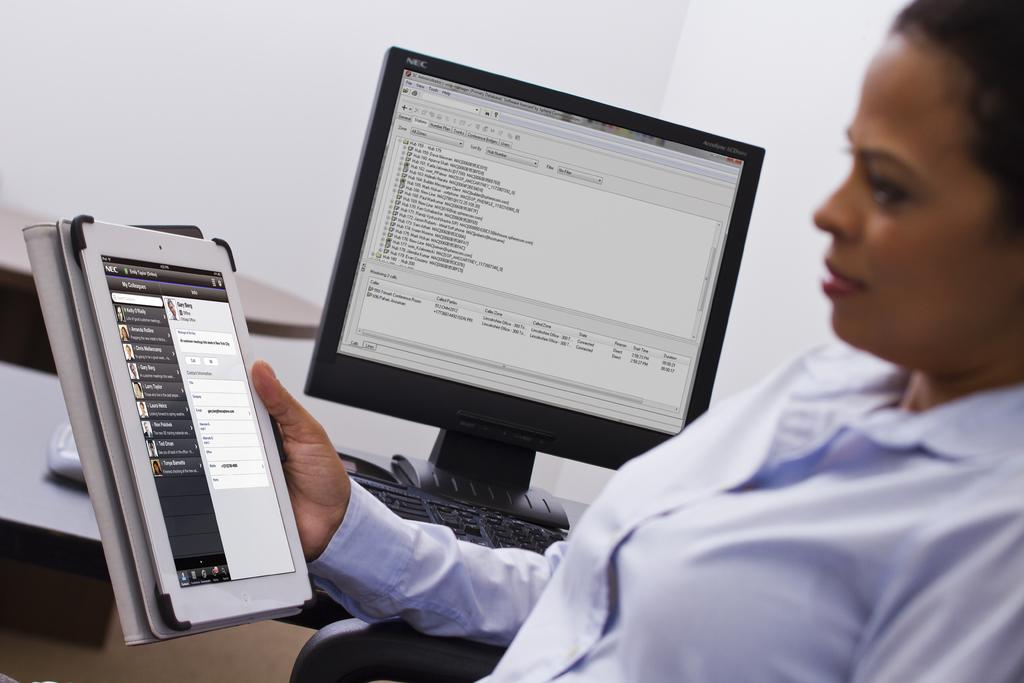Who is the main subject in the image? There is a woman in the image. What is the woman holding in the image? The woman is holding an iPad. What can be seen in the background of the image? There is a monitor, a keyboard on a table, and a plain wall in the background of the image. What type of cactus is present on the woman's desk in the image? There is no cactus present on the woman's desk or in the image. 